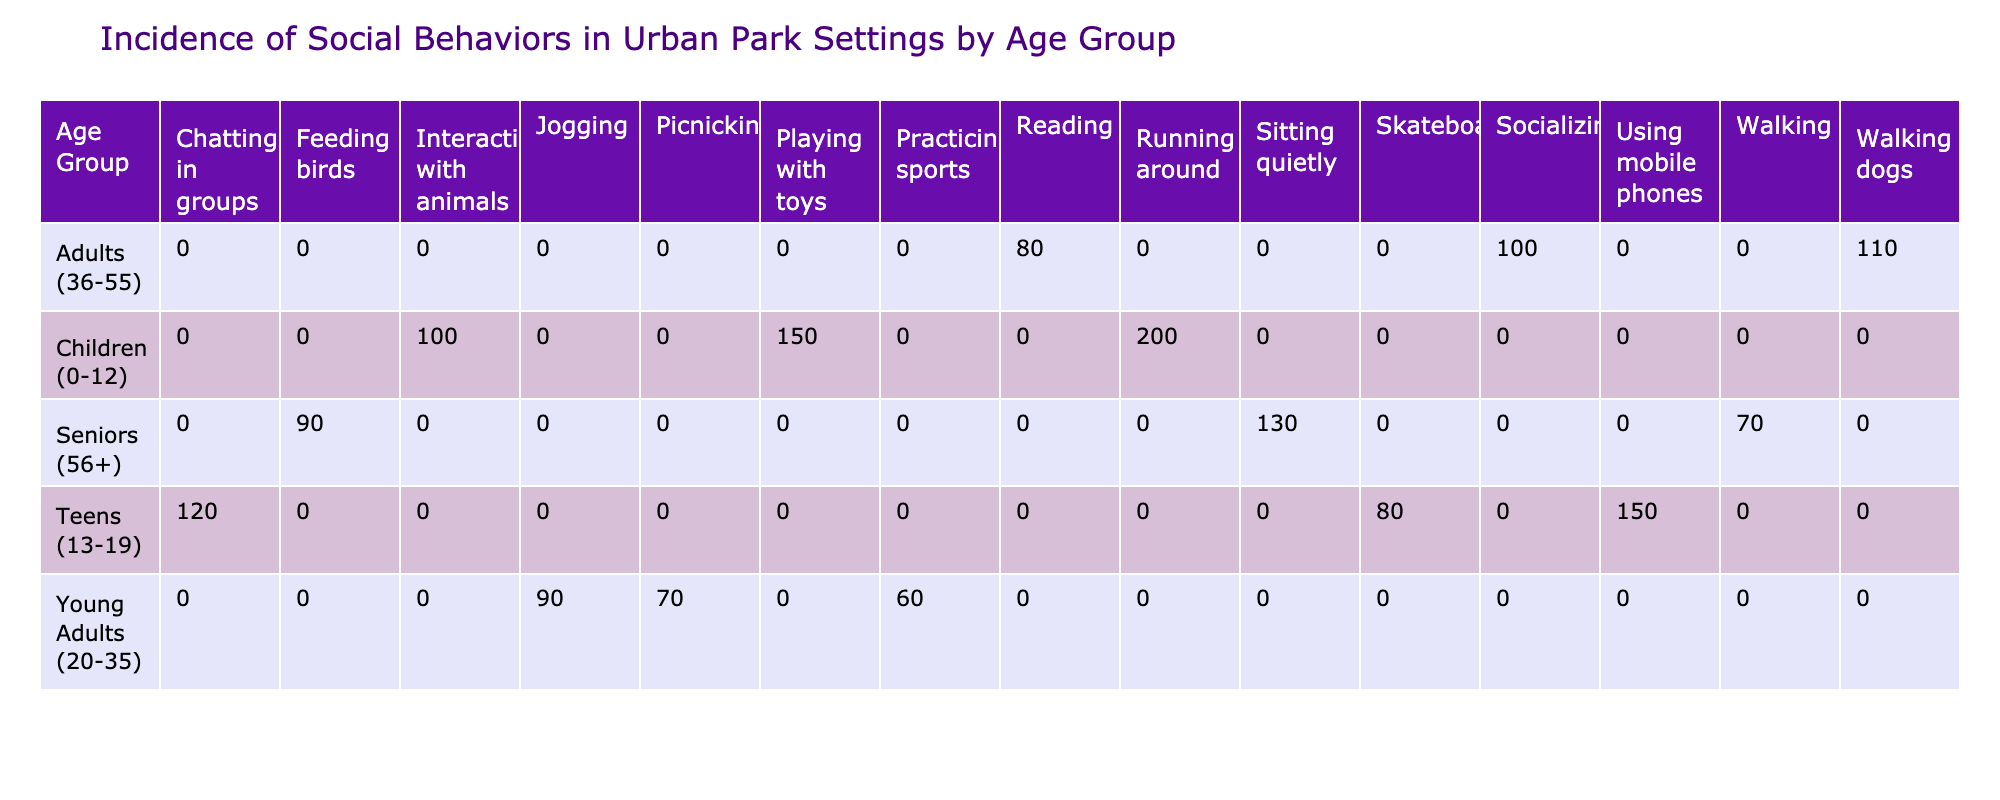What is the total count of social behaviors for the age group "Teens (13-19)"? To find the total count for "Teens (13-19)", we sum the values under this age group: Chatting in groups (120) + Skateboarding (80) + Using mobile phones (150) = 350.
Answer: 350 Which age group exhibits the highest incidence of "Playing with toys"? "Playing with toys" is only listed under the age group "Children (0-12)", with a count of 150. No other age group has this behavior reported.
Answer: Children (0-12) Is the number of "Socializing" behaviors greater than the number of "Jogging" behaviors? "Socializing" is listed under Adults (36-55) with a count of 100, while "Jogging" is listed under Young Adults (20-35) with a count of 90. Since 100 is greater than 90, the statement is true.
Answer: Yes What is the difference in counts between "Interacting with animals" and "Feeding birds"? "Interacting with animals" for Children (0-12) has a count of 100, while "Feeding birds" for Seniors (56+) has a count of 90. The difference is 100 - 90 = 10.
Answer: 10 Which social behavior is most common among Seniors (56+)? To find the most common behavior among Seniors, we compare the counts: Sitting quietly (130), Feeding birds (90), and Walking (70). The highest count is Sitting quietly at 130.
Answer: Sitting quietly How many total social behaviors are reported for the age group "Young Adults (20-35)"? For the age group Young Adults (20-35), the social behaviors reported are Jogging (90), Picnicking (70), and Practicing sports (60). The total is 90 + 70 + 60 = 220.
Answer: 220 Is there any age group that has a behavior count less than 70? The counts for all behaviors across age groups are examined. For Young Adults (20-35), Practicing sports is recorded at 60, which is less than 70. Therefore, there is at least one instance of a count below 70.
Answer: Yes What is the total count for all "Sitting quietly" and "Reading" behaviors across age groups? For "Sitting quietly," the count is 130 (Seniors) and for "Reading," the count is 80 (Adults). Summing these gives 130 + 80 = 210.
Answer: 210 What percentage of total behaviors reported are "Chatting in groups"? The total count across all behaviors is calculated first: 150 + 200 + 100 + 120 + 80 + 150 + 90 + 70 + 60 + 110 + 80 + 100 + 130 + 90 + 70 = 1,500. The count for "Chatting in groups" is 120. Thus, the percentage is (120/1500)*100 = 8%.
Answer: 8% 